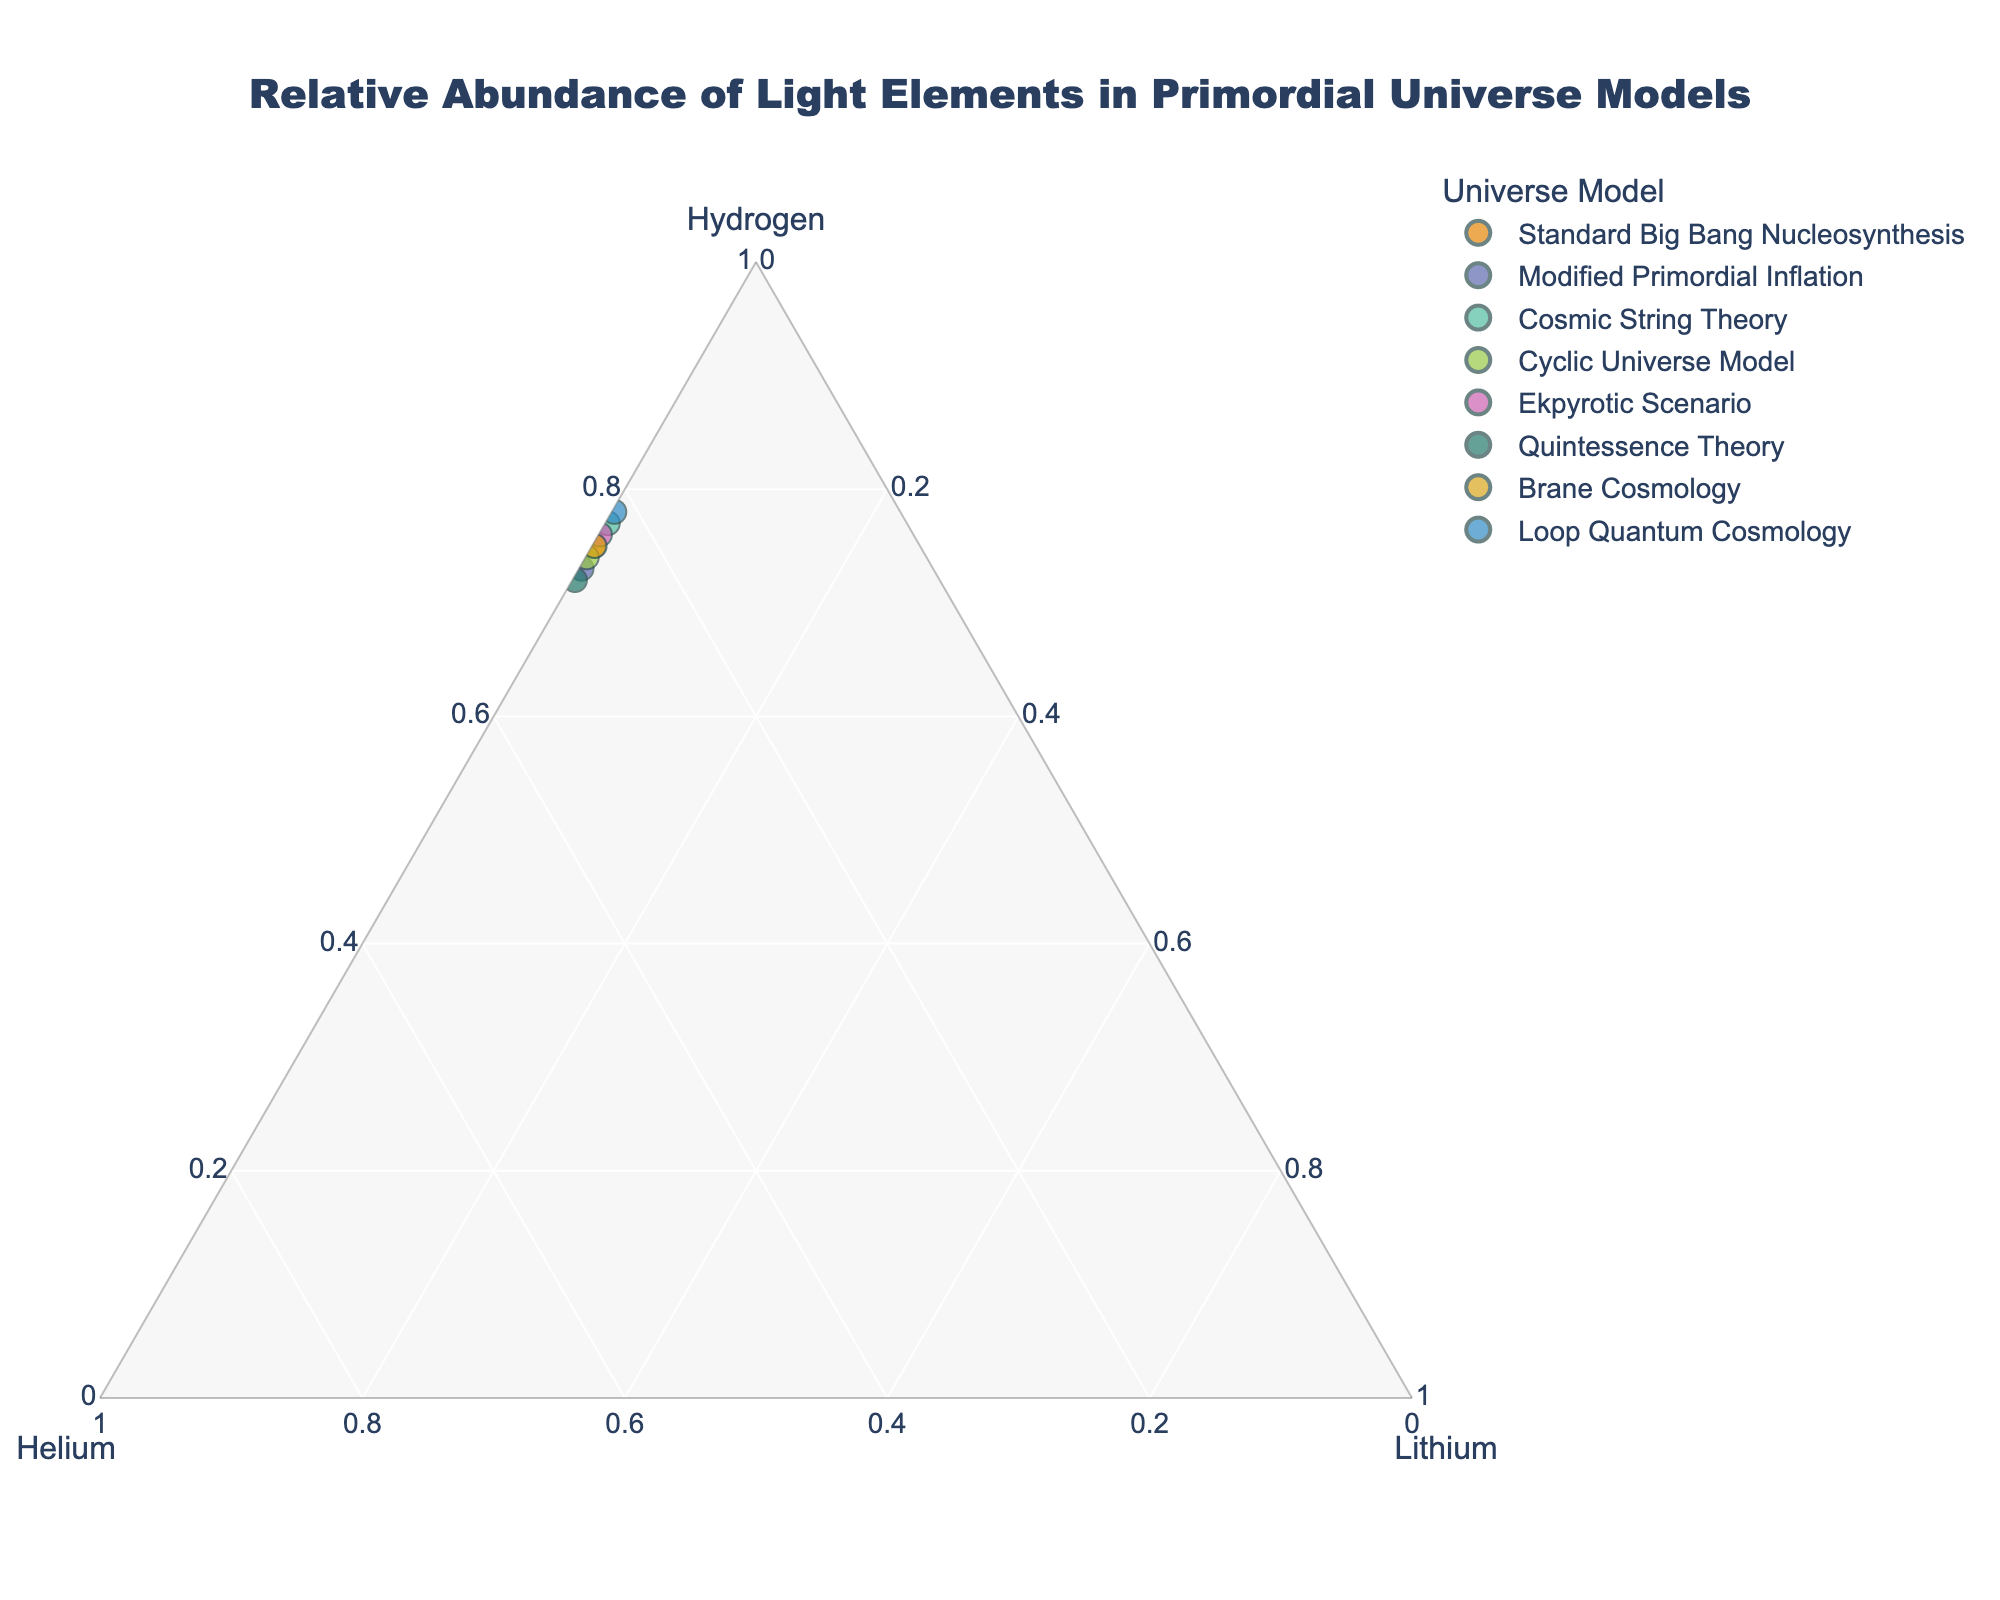what is the title of the plot? The title is usually located at the top-center of the plot. For this specific plot, it is "Relative Abundance of Light Elements in Primordial Universe Models".
Answer: Relative Abundance of Light Elements in Primordial Universe Models what are the three axes representing in this figure? The ternary plot has three axes representing the relative abundance of different light elements. Specifically, the axes are labeled for Hydrogen, Helium, and Lithium.
Answer: Hydrogen, Helium, Lithium which model has the highest relative abundance of Hydrogen? To find the model with the highest relative abundance of Hydrogen, we locate the data point closest to the vertex labeled "Hydrogen". This point corresponds to Loop Quantum Cosmology with 0.78 Hydrogen.
Answer: Loop Quantum Cosmology which model has the highest relative abundance of Helium? To find the model with the highest relative abundance of Helium, we locate the data point closest to the vertex labeled "Helium". This point corresponds to Quintessence Theory with 0.278 Helium.
Answer: Quintessence Theory what is the sum of the relative abundances of Hydrogen and Helium for the Standard Big Bang Nucleosynthesis model? The Standard Big Bang Nucleosynthesis model has 0.75 Hydrogen and 0.249 Helium. Adding them together: 0.75 + 0.249 = 0.999.
Answer: 0.999 which model has the same relative abundance of Lithium but different relative abundances of Hydrogen and Helium when compared to the Standard Big Bang Nucleosynthesis model? The Standard Big Bang Nucleosynthesis model has 0.001 Lithium. The Cyclic Universe Model and Ekpyrotic Scenario also have 0.001 Lithium but different amounts of Hydrogen and Helium.
Answer: Cyclic Universe Model, Ekpyrotic Scenario which two models have the same relative abundance of Lithium? We observe the data points and identify that Modified Primordial Inflation, Cosmic String Theory, Quintessence Theory, Brane Cosmology, and Loop Quantum Cosmology all have 0.002 Lithium.
Answer: Modified Primordial Inflation, Cosmic String Theory, Quintessence Theory, Brane Cosmology, Loop Quantum Cosmology which models show a decrease in Helium relative abundance compared to the Standard Big Bang Nucleosynthesis model? The Standard Big Bang Nucleosynthesis model has 0.249 Helium. Models with lower Helium include Cosmic String Theory (0.228), Ekpyrotic Scenario (0.239), and Loop Quantum Cosmology (0.218).
Answer: Cosmic String Theory, Ekpyrotic Scenario, Loop Quantum Cosmology what is the average relative abundance of Hydrogen across all models? Calculate the sum of Hydrogen values: 0.75 + 0.73 + 0.77 + 0.74 + 0.76 + 0.72 + 0.75 + 0.78 = 6.3. The total number of models is 8. The average is 6.3 / 8 = 0.7875.
Answer: 0.7375 